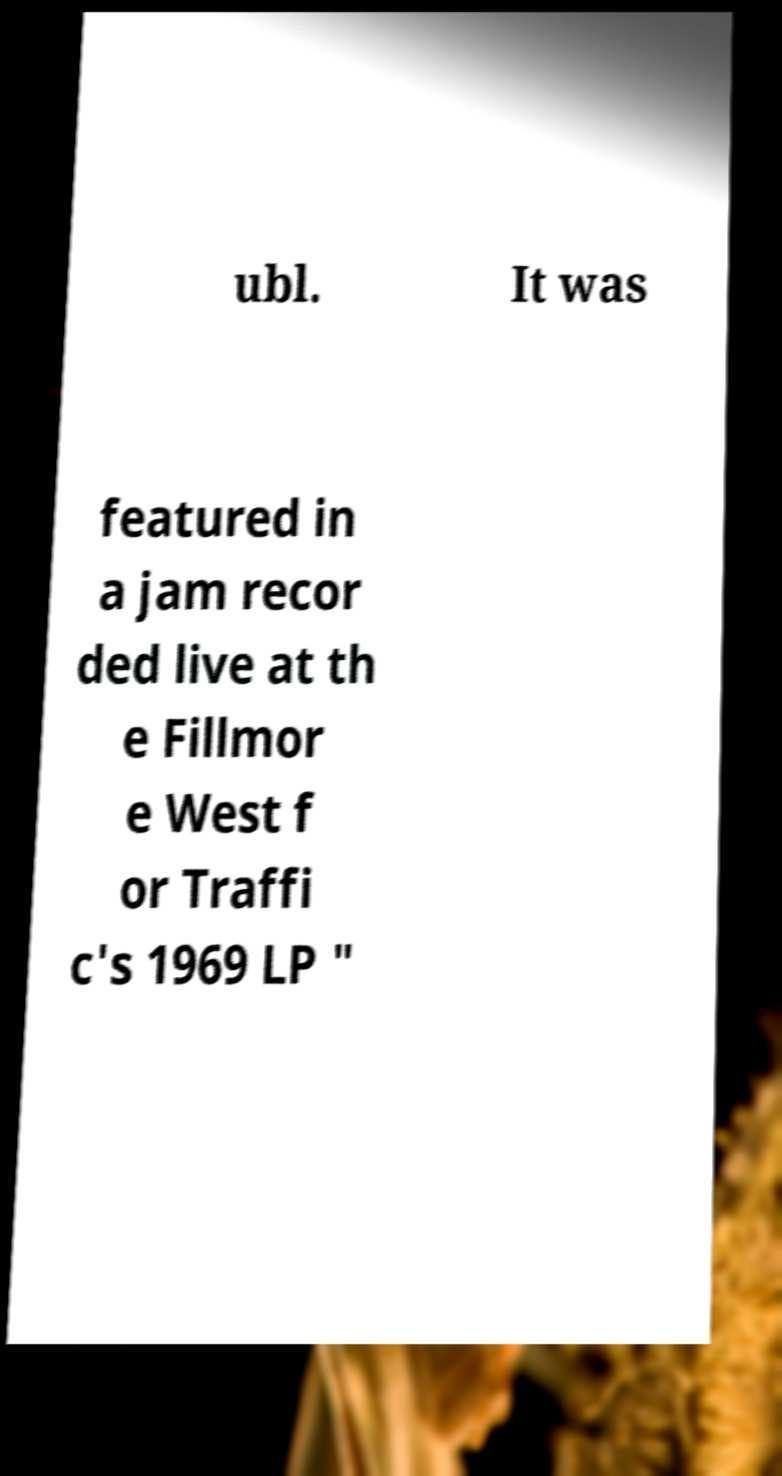What messages or text are displayed in this image? I need them in a readable, typed format. ubl. It was featured in a jam recor ded live at th e Fillmor e West f or Traffi c's 1969 LP " 